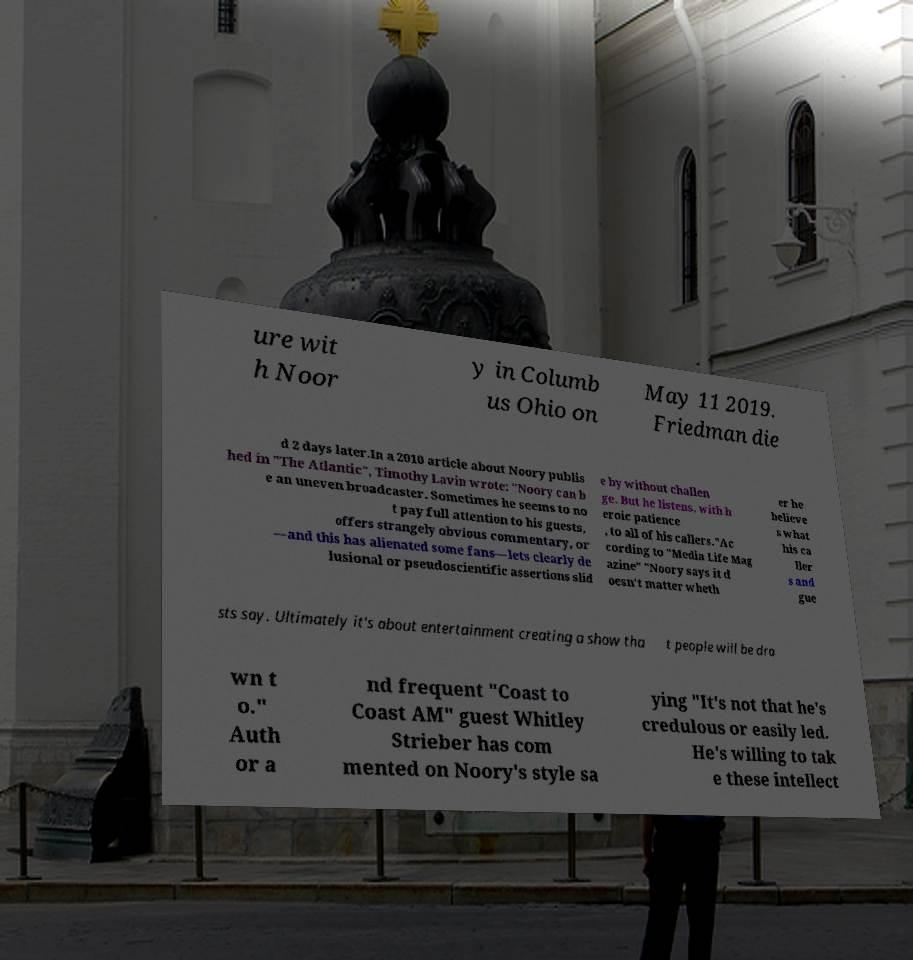What messages or text are displayed in this image? I need them in a readable, typed format. ure wit h Noor y in Columb us Ohio on May 11 2019. Friedman die d 2 days later.In a 2010 article about Noory publis hed in "The Atlantic", Timothy Lavin wrote: "Noory can b e an uneven broadcaster. Sometimes he seems to no t pay full attention to his guests, offers strangely obvious commentary, or —and this has alienated some fans—lets clearly de lusional or pseudoscientific assertions slid e by without challen ge. But he listens, with h eroic patience , to all of his callers."Ac cording to "Media Life Mag azine" "Noory says it d oesn't matter wheth er he believe s what his ca ller s and gue sts say. Ultimately it's about entertainment creating a show tha t people will be dra wn t o." Auth or a nd frequent "Coast to Coast AM" guest Whitley Strieber has com mented on Noory's style sa ying "It's not that he's credulous or easily led. He's willing to tak e these intellect 